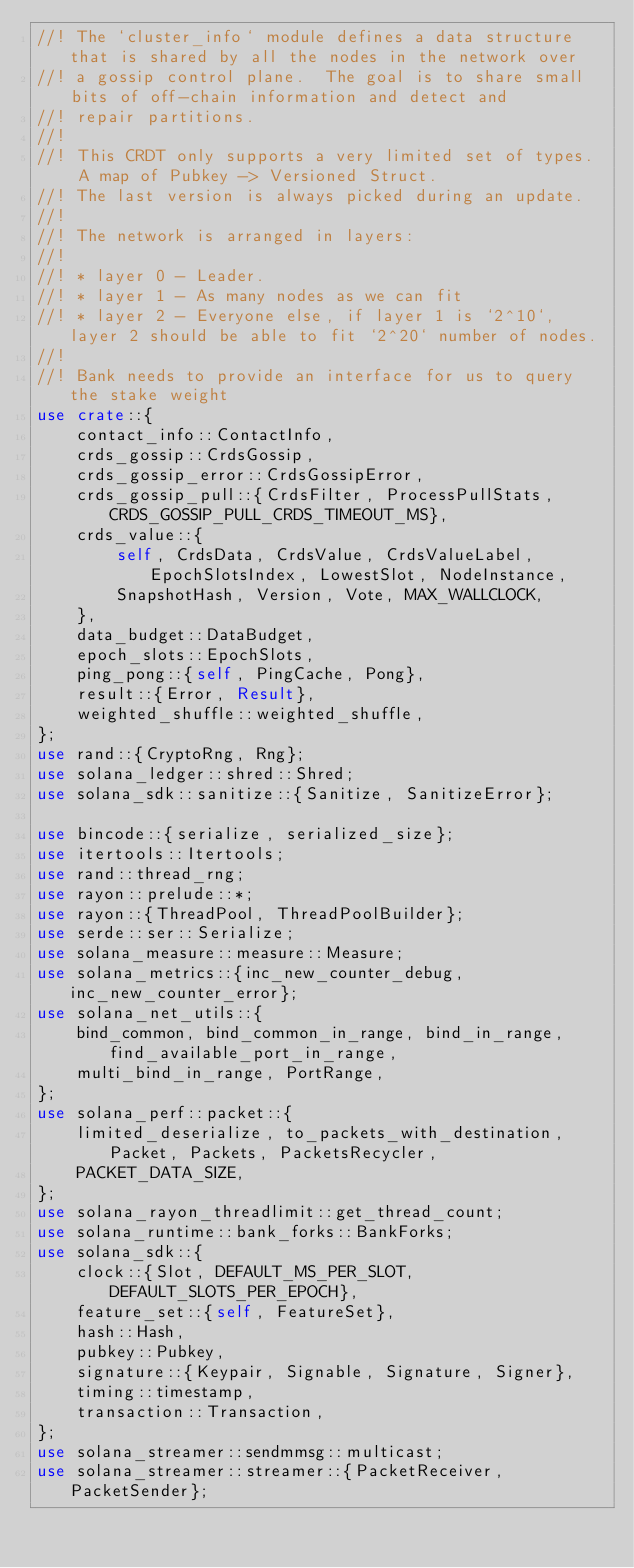Convert code to text. <code><loc_0><loc_0><loc_500><loc_500><_Rust_>//! The `cluster_info` module defines a data structure that is shared by all the nodes in the network over
//! a gossip control plane.  The goal is to share small bits of off-chain information and detect and
//! repair partitions.
//!
//! This CRDT only supports a very limited set of types.  A map of Pubkey -> Versioned Struct.
//! The last version is always picked during an update.
//!
//! The network is arranged in layers:
//!
//! * layer 0 - Leader.
//! * layer 1 - As many nodes as we can fit
//! * layer 2 - Everyone else, if layer 1 is `2^10`, layer 2 should be able to fit `2^20` number of nodes.
//!
//! Bank needs to provide an interface for us to query the stake weight
use crate::{
    contact_info::ContactInfo,
    crds_gossip::CrdsGossip,
    crds_gossip_error::CrdsGossipError,
    crds_gossip_pull::{CrdsFilter, ProcessPullStats, CRDS_GOSSIP_PULL_CRDS_TIMEOUT_MS},
    crds_value::{
        self, CrdsData, CrdsValue, CrdsValueLabel, EpochSlotsIndex, LowestSlot, NodeInstance,
        SnapshotHash, Version, Vote, MAX_WALLCLOCK,
    },
    data_budget::DataBudget,
    epoch_slots::EpochSlots,
    ping_pong::{self, PingCache, Pong},
    result::{Error, Result},
    weighted_shuffle::weighted_shuffle,
};
use rand::{CryptoRng, Rng};
use solana_ledger::shred::Shred;
use solana_sdk::sanitize::{Sanitize, SanitizeError};

use bincode::{serialize, serialized_size};
use itertools::Itertools;
use rand::thread_rng;
use rayon::prelude::*;
use rayon::{ThreadPool, ThreadPoolBuilder};
use serde::ser::Serialize;
use solana_measure::measure::Measure;
use solana_metrics::{inc_new_counter_debug, inc_new_counter_error};
use solana_net_utils::{
    bind_common, bind_common_in_range, bind_in_range, find_available_port_in_range,
    multi_bind_in_range, PortRange,
};
use solana_perf::packet::{
    limited_deserialize, to_packets_with_destination, Packet, Packets, PacketsRecycler,
    PACKET_DATA_SIZE,
};
use solana_rayon_threadlimit::get_thread_count;
use solana_runtime::bank_forks::BankForks;
use solana_sdk::{
    clock::{Slot, DEFAULT_MS_PER_SLOT, DEFAULT_SLOTS_PER_EPOCH},
    feature_set::{self, FeatureSet},
    hash::Hash,
    pubkey::Pubkey,
    signature::{Keypair, Signable, Signature, Signer},
    timing::timestamp,
    transaction::Transaction,
};
use solana_streamer::sendmmsg::multicast;
use solana_streamer::streamer::{PacketReceiver, PacketSender};</code> 